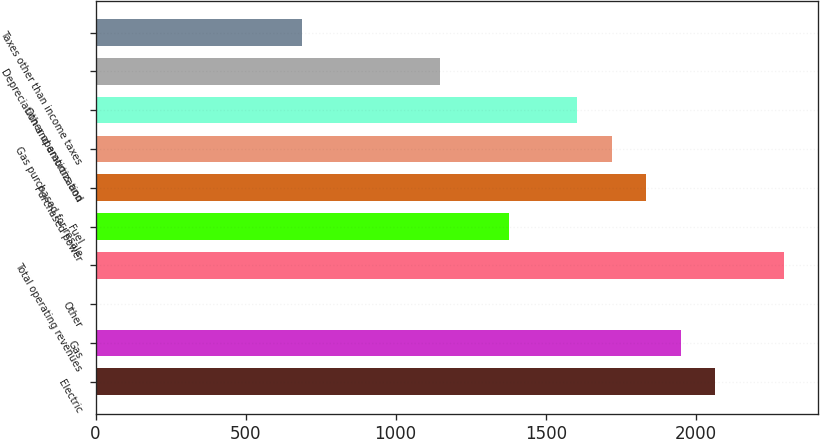Convert chart. <chart><loc_0><loc_0><loc_500><loc_500><bar_chart><fcel>Electric<fcel>Gas<fcel>Other<fcel>Total operating revenues<fcel>Fuel<fcel>Purchased power<fcel>Gas purchased for resale<fcel>Other operations and<fcel>Depreciation and amortization<fcel>Taxes other than income taxes<nl><fcel>2063.8<fcel>1949.2<fcel>1<fcel>2293<fcel>1376.2<fcel>1834.6<fcel>1720<fcel>1605.4<fcel>1147<fcel>688.6<nl></chart> 